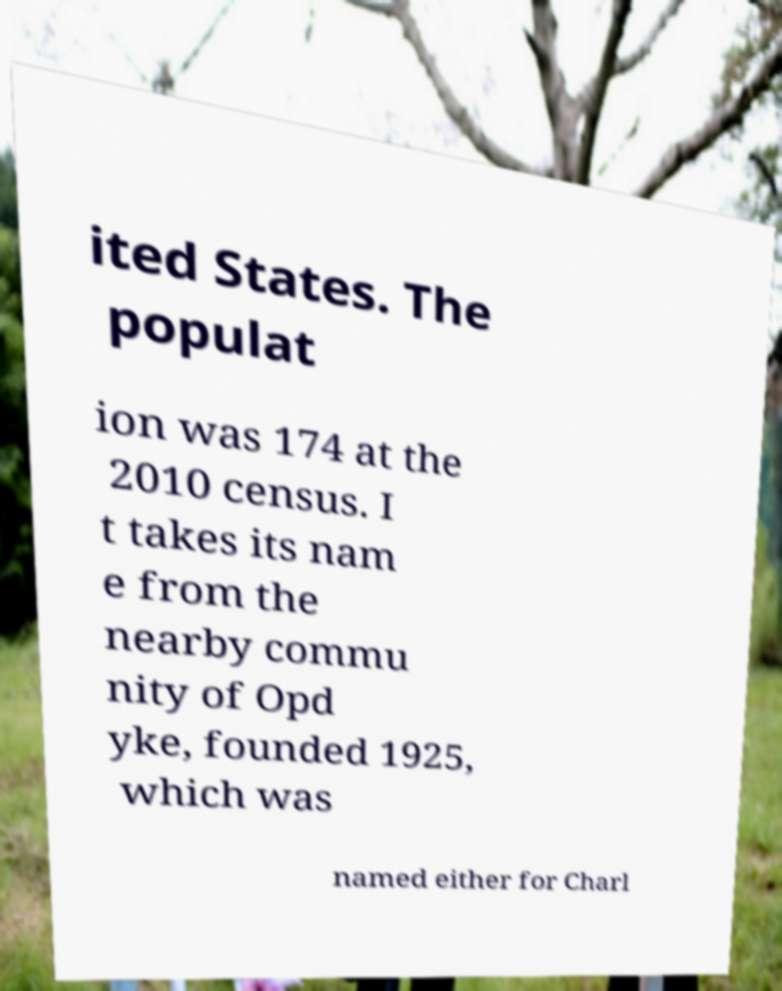What messages or text are displayed in this image? I need them in a readable, typed format. ited States. The populat ion was 174 at the 2010 census. I t takes its nam e from the nearby commu nity of Opd yke, founded 1925, which was named either for Charl 